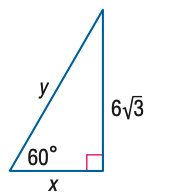Answer the mathemtical geometry problem and directly provide the correct option letter.
Question: Find x.
Choices: A: 6 B: 6 \sqrt { 3 } C: 12 D: 18 A 